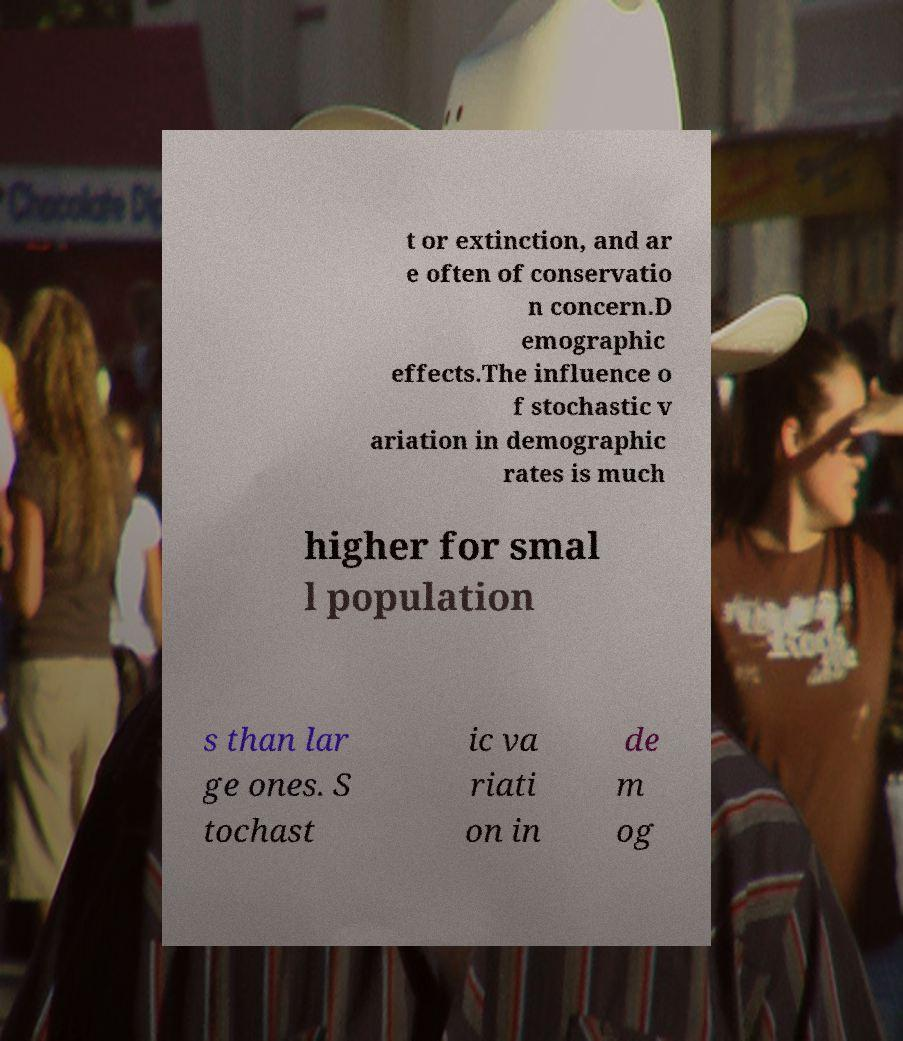What messages or text are displayed in this image? I need them in a readable, typed format. t or extinction, and ar e often of conservatio n concern.D emographic effects.The influence o f stochastic v ariation in demographic rates is much higher for smal l population s than lar ge ones. S tochast ic va riati on in de m og 